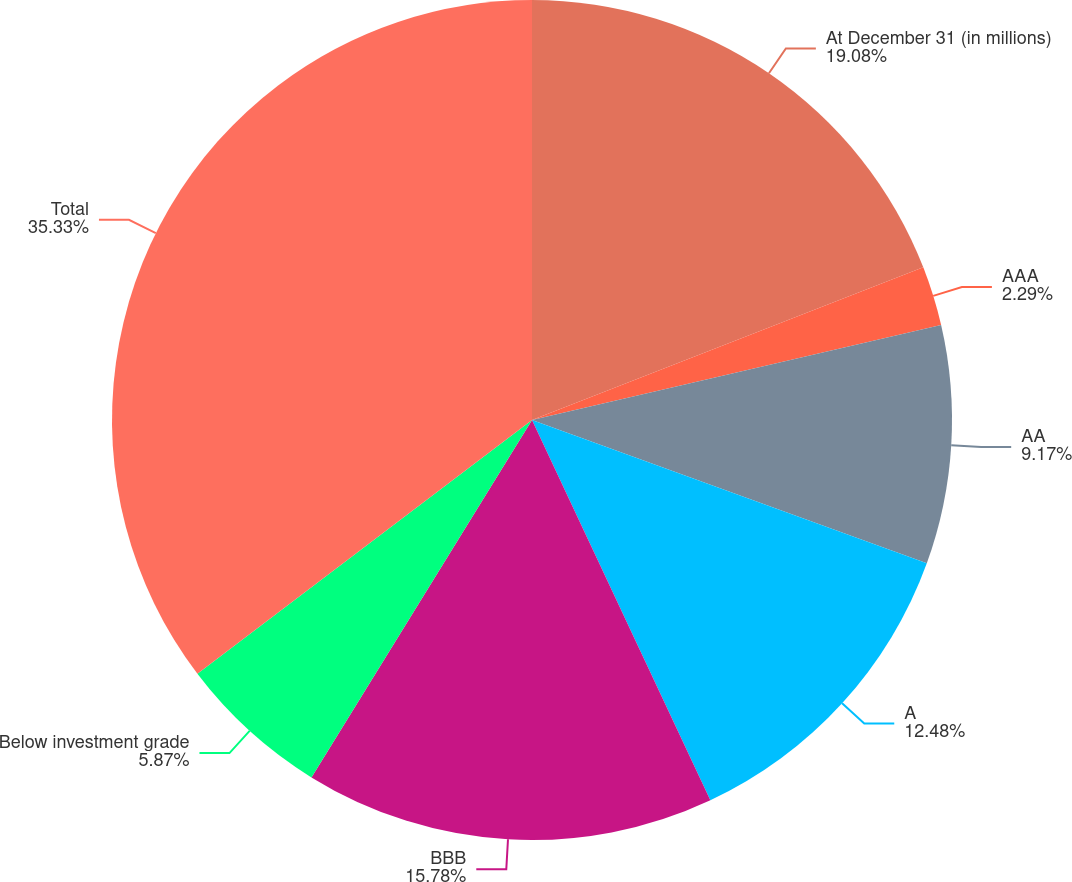Convert chart. <chart><loc_0><loc_0><loc_500><loc_500><pie_chart><fcel>At December 31 (in millions)<fcel>AAA<fcel>AA<fcel>A<fcel>BBB<fcel>Below investment grade<fcel>Total<nl><fcel>19.08%<fcel>2.29%<fcel>9.17%<fcel>12.48%<fcel>15.78%<fcel>5.87%<fcel>35.33%<nl></chart> 